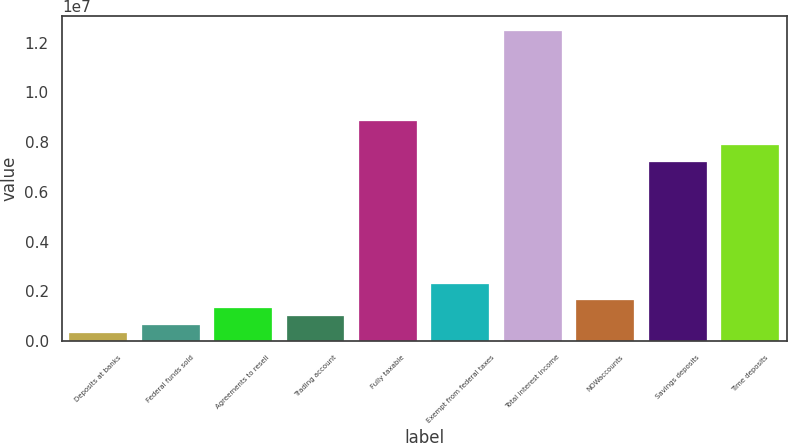Convert chart to OTSL. <chart><loc_0><loc_0><loc_500><loc_500><bar_chart><fcel>Deposits at banks<fcel>Federal funds sold<fcel>Agreements to resell<fcel>Trading account<fcel>Fully taxable<fcel>Exempt from federal taxes<fcel>Total interest income<fcel>NOWaccounts<fcel>Savings deposits<fcel>Time deposits<nl><fcel>327764<fcel>655522<fcel>1.31104e+06<fcel>983281<fcel>8.84949e+06<fcel>2.29432e+06<fcel>1.24548e+07<fcel>1.6388e+06<fcel>7.21069e+06<fcel>7.86621e+06<nl></chart> 